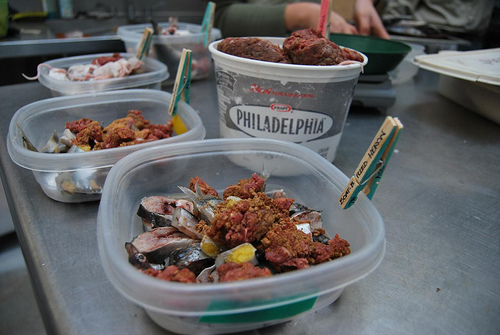<image>
Is there a food in the bowl? No. The food is not contained within the bowl. These objects have a different spatial relationship. 